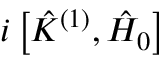Convert formula to latex. <formula><loc_0><loc_0><loc_500><loc_500>i \left [ \hat { K } ^ { ( 1 ) } , \hat { H } _ { 0 } \right ]</formula> 